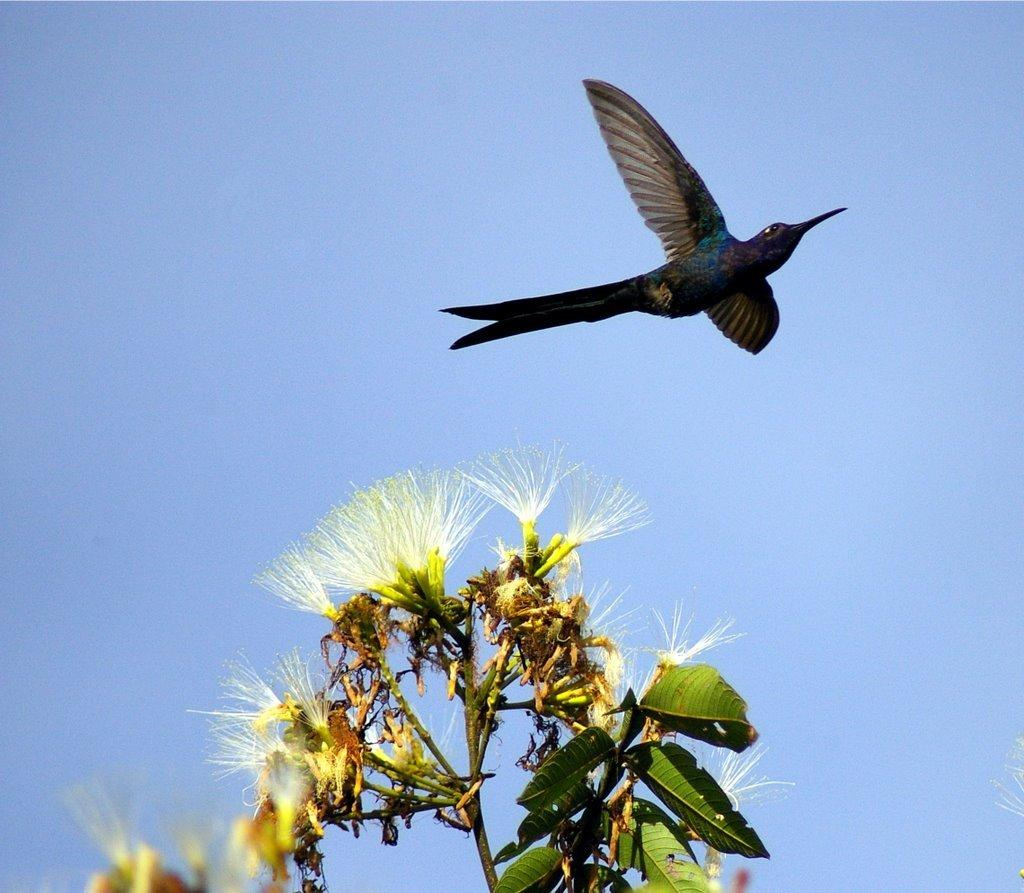What type of plant is visible in the image? There is a white flower plant in the image. What is happening in the sky in the image? A bird is flying in the sky in the image. How many letters are visible on the bird in the image? There are no letters visible on the bird in the image; it is a bird flying in the sky. 